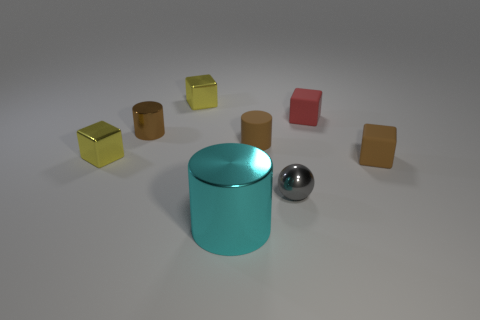Add 1 small metal objects. How many objects exist? 9 Subtract all cylinders. How many objects are left? 5 Add 6 tiny blocks. How many tiny blocks are left? 10 Add 2 tiny yellow metallic objects. How many tiny yellow metallic objects exist? 4 Subtract 0 yellow cylinders. How many objects are left? 8 Subtract all brown rubber cylinders. Subtract all gray metal balls. How many objects are left? 6 